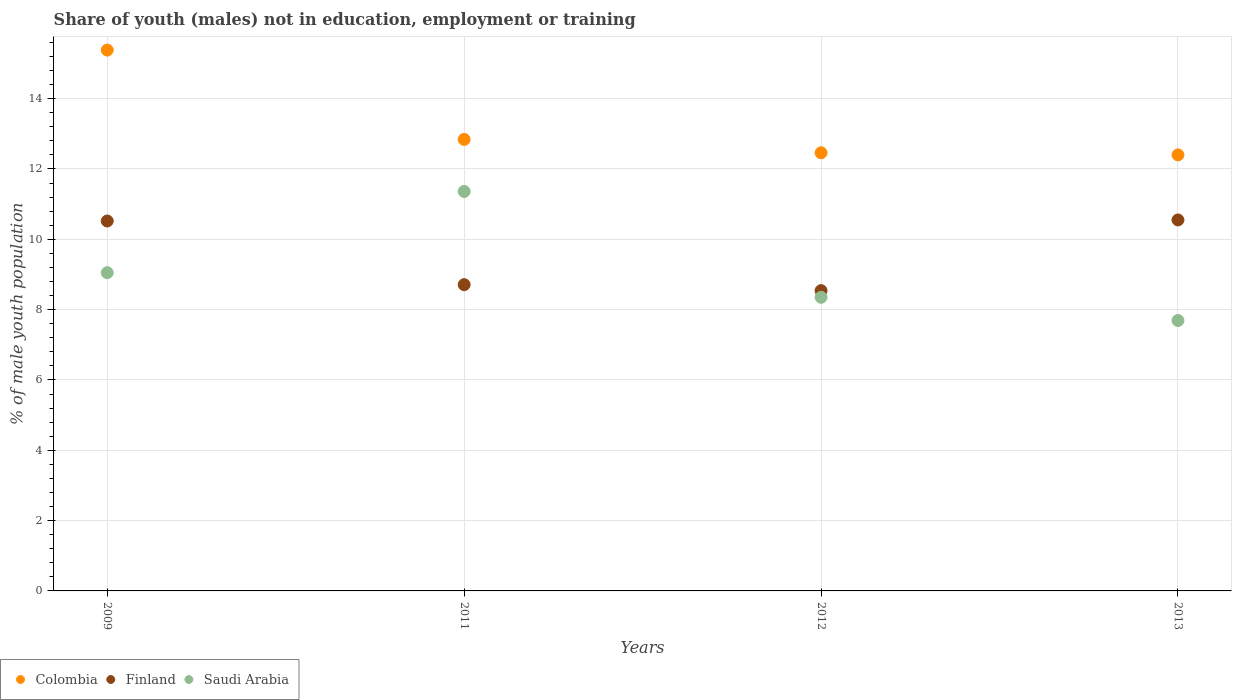What is the percentage of unemployed males population in in Finland in 2012?
Your answer should be very brief. 8.54. Across all years, what is the maximum percentage of unemployed males population in in Colombia?
Offer a very short reply. 15.38. Across all years, what is the minimum percentage of unemployed males population in in Finland?
Provide a short and direct response. 8.54. In which year was the percentage of unemployed males population in in Saudi Arabia minimum?
Offer a very short reply. 2013. What is the total percentage of unemployed males population in in Colombia in the graph?
Provide a succinct answer. 53.08. What is the difference between the percentage of unemployed males population in in Saudi Arabia in 2012 and that in 2013?
Provide a short and direct response. 0.66. What is the difference between the percentage of unemployed males population in in Finland in 2013 and the percentage of unemployed males population in in Colombia in 2009?
Your answer should be compact. -4.83. What is the average percentage of unemployed males population in in Colombia per year?
Your answer should be very brief. 13.27. In the year 2012, what is the difference between the percentage of unemployed males population in in Colombia and percentage of unemployed males population in in Saudi Arabia?
Keep it short and to the point. 4.11. What is the ratio of the percentage of unemployed males population in in Saudi Arabia in 2011 to that in 2013?
Provide a short and direct response. 1.48. Is the difference between the percentage of unemployed males population in in Colombia in 2011 and 2013 greater than the difference between the percentage of unemployed males population in in Saudi Arabia in 2011 and 2013?
Your response must be concise. No. What is the difference between the highest and the second highest percentage of unemployed males population in in Saudi Arabia?
Make the answer very short. 2.31. What is the difference between the highest and the lowest percentage of unemployed males population in in Colombia?
Give a very brief answer. 2.98. In how many years, is the percentage of unemployed males population in in Saudi Arabia greater than the average percentage of unemployed males population in in Saudi Arabia taken over all years?
Offer a very short reply. 1. Is the percentage of unemployed males population in in Colombia strictly less than the percentage of unemployed males population in in Finland over the years?
Ensure brevity in your answer.  No. How many years are there in the graph?
Offer a very short reply. 4. Are the values on the major ticks of Y-axis written in scientific E-notation?
Provide a short and direct response. No. Does the graph contain any zero values?
Offer a terse response. No. Does the graph contain grids?
Your answer should be compact. Yes. Where does the legend appear in the graph?
Ensure brevity in your answer.  Bottom left. How are the legend labels stacked?
Offer a terse response. Horizontal. What is the title of the graph?
Provide a succinct answer. Share of youth (males) not in education, employment or training. What is the label or title of the X-axis?
Keep it short and to the point. Years. What is the label or title of the Y-axis?
Your answer should be compact. % of male youth population. What is the % of male youth population in Colombia in 2009?
Offer a very short reply. 15.38. What is the % of male youth population in Finland in 2009?
Make the answer very short. 10.52. What is the % of male youth population of Saudi Arabia in 2009?
Offer a very short reply. 9.05. What is the % of male youth population in Colombia in 2011?
Keep it short and to the point. 12.84. What is the % of male youth population in Finland in 2011?
Your answer should be very brief. 8.71. What is the % of male youth population in Saudi Arabia in 2011?
Your response must be concise. 11.36. What is the % of male youth population of Colombia in 2012?
Keep it short and to the point. 12.46. What is the % of male youth population of Finland in 2012?
Ensure brevity in your answer.  8.54. What is the % of male youth population in Saudi Arabia in 2012?
Your answer should be compact. 8.35. What is the % of male youth population of Colombia in 2013?
Your response must be concise. 12.4. What is the % of male youth population of Finland in 2013?
Keep it short and to the point. 10.55. What is the % of male youth population in Saudi Arabia in 2013?
Your answer should be very brief. 7.69. Across all years, what is the maximum % of male youth population of Colombia?
Provide a succinct answer. 15.38. Across all years, what is the maximum % of male youth population in Finland?
Keep it short and to the point. 10.55. Across all years, what is the maximum % of male youth population of Saudi Arabia?
Keep it short and to the point. 11.36. Across all years, what is the minimum % of male youth population of Colombia?
Ensure brevity in your answer.  12.4. Across all years, what is the minimum % of male youth population of Finland?
Your answer should be very brief. 8.54. Across all years, what is the minimum % of male youth population in Saudi Arabia?
Provide a short and direct response. 7.69. What is the total % of male youth population of Colombia in the graph?
Ensure brevity in your answer.  53.08. What is the total % of male youth population in Finland in the graph?
Ensure brevity in your answer.  38.32. What is the total % of male youth population of Saudi Arabia in the graph?
Ensure brevity in your answer.  36.45. What is the difference between the % of male youth population in Colombia in 2009 and that in 2011?
Provide a succinct answer. 2.54. What is the difference between the % of male youth population of Finland in 2009 and that in 2011?
Your response must be concise. 1.81. What is the difference between the % of male youth population in Saudi Arabia in 2009 and that in 2011?
Your answer should be very brief. -2.31. What is the difference between the % of male youth population in Colombia in 2009 and that in 2012?
Keep it short and to the point. 2.92. What is the difference between the % of male youth population of Finland in 2009 and that in 2012?
Offer a very short reply. 1.98. What is the difference between the % of male youth population in Colombia in 2009 and that in 2013?
Your answer should be compact. 2.98. What is the difference between the % of male youth population in Finland in 2009 and that in 2013?
Keep it short and to the point. -0.03. What is the difference between the % of male youth population of Saudi Arabia in 2009 and that in 2013?
Ensure brevity in your answer.  1.36. What is the difference between the % of male youth population in Colombia in 2011 and that in 2012?
Offer a very short reply. 0.38. What is the difference between the % of male youth population in Finland in 2011 and that in 2012?
Your answer should be very brief. 0.17. What is the difference between the % of male youth population in Saudi Arabia in 2011 and that in 2012?
Ensure brevity in your answer.  3.01. What is the difference between the % of male youth population of Colombia in 2011 and that in 2013?
Offer a very short reply. 0.44. What is the difference between the % of male youth population in Finland in 2011 and that in 2013?
Your response must be concise. -1.84. What is the difference between the % of male youth population in Saudi Arabia in 2011 and that in 2013?
Offer a terse response. 3.67. What is the difference between the % of male youth population in Colombia in 2012 and that in 2013?
Provide a short and direct response. 0.06. What is the difference between the % of male youth population of Finland in 2012 and that in 2013?
Offer a terse response. -2.01. What is the difference between the % of male youth population of Saudi Arabia in 2012 and that in 2013?
Offer a terse response. 0.66. What is the difference between the % of male youth population of Colombia in 2009 and the % of male youth population of Finland in 2011?
Give a very brief answer. 6.67. What is the difference between the % of male youth population of Colombia in 2009 and the % of male youth population of Saudi Arabia in 2011?
Offer a terse response. 4.02. What is the difference between the % of male youth population in Finland in 2009 and the % of male youth population in Saudi Arabia in 2011?
Ensure brevity in your answer.  -0.84. What is the difference between the % of male youth population of Colombia in 2009 and the % of male youth population of Finland in 2012?
Your answer should be compact. 6.84. What is the difference between the % of male youth population in Colombia in 2009 and the % of male youth population in Saudi Arabia in 2012?
Your answer should be very brief. 7.03. What is the difference between the % of male youth population in Finland in 2009 and the % of male youth population in Saudi Arabia in 2012?
Your answer should be compact. 2.17. What is the difference between the % of male youth population of Colombia in 2009 and the % of male youth population of Finland in 2013?
Your response must be concise. 4.83. What is the difference between the % of male youth population of Colombia in 2009 and the % of male youth population of Saudi Arabia in 2013?
Provide a succinct answer. 7.69. What is the difference between the % of male youth population in Finland in 2009 and the % of male youth population in Saudi Arabia in 2013?
Offer a very short reply. 2.83. What is the difference between the % of male youth population of Colombia in 2011 and the % of male youth population of Finland in 2012?
Give a very brief answer. 4.3. What is the difference between the % of male youth population in Colombia in 2011 and the % of male youth population in Saudi Arabia in 2012?
Give a very brief answer. 4.49. What is the difference between the % of male youth population of Finland in 2011 and the % of male youth population of Saudi Arabia in 2012?
Your answer should be compact. 0.36. What is the difference between the % of male youth population in Colombia in 2011 and the % of male youth population in Finland in 2013?
Offer a very short reply. 2.29. What is the difference between the % of male youth population of Colombia in 2011 and the % of male youth population of Saudi Arabia in 2013?
Offer a very short reply. 5.15. What is the difference between the % of male youth population in Colombia in 2012 and the % of male youth population in Finland in 2013?
Offer a terse response. 1.91. What is the difference between the % of male youth population of Colombia in 2012 and the % of male youth population of Saudi Arabia in 2013?
Provide a succinct answer. 4.77. What is the average % of male youth population of Colombia per year?
Ensure brevity in your answer.  13.27. What is the average % of male youth population of Finland per year?
Offer a terse response. 9.58. What is the average % of male youth population of Saudi Arabia per year?
Offer a terse response. 9.11. In the year 2009, what is the difference between the % of male youth population of Colombia and % of male youth population of Finland?
Your answer should be very brief. 4.86. In the year 2009, what is the difference between the % of male youth population in Colombia and % of male youth population in Saudi Arabia?
Your response must be concise. 6.33. In the year 2009, what is the difference between the % of male youth population in Finland and % of male youth population in Saudi Arabia?
Provide a succinct answer. 1.47. In the year 2011, what is the difference between the % of male youth population of Colombia and % of male youth population of Finland?
Ensure brevity in your answer.  4.13. In the year 2011, what is the difference between the % of male youth population of Colombia and % of male youth population of Saudi Arabia?
Give a very brief answer. 1.48. In the year 2011, what is the difference between the % of male youth population of Finland and % of male youth population of Saudi Arabia?
Offer a terse response. -2.65. In the year 2012, what is the difference between the % of male youth population in Colombia and % of male youth population in Finland?
Keep it short and to the point. 3.92. In the year 2012, what is the difference between the % of male youth population in Colombia and % of male youth population in Saudi Arabia?
Offer a terse response. 4.11. In the year 2012, what is the difference between the % of male youth population of Finland and % of male youth population of Saudi Arabia?
Your response must be concise. 0.19. In the year 2013, what is the difference between the % of male youth population in Colombia and % of male youth population in Finland?
Provide a short and direct response. 1.85. In the year 2013, what is the difference between the % of male youth population in Colombia and % of male youth population in Saudi Arabia?
Provide a succinct answer. 4.71. In the year 2013, what is the difference between the % of male youth population in Finland and % of male youth population in Saudi Arabia?
Offer a very short reply. 2.86. What is the ratio of the % of male youth population of Colombia in 2009 to that in 2011?
Keep it short and to the point. 1.2. What is the ratio of the % of male youth population in Finland in 2009 to that in 2011?
Provide a short and direct response. 1.21. What is the ratio of the % of male youth population in Saudi Arabia in 2009 to that in 2011?
Your answer should be compact. 0.8. What is the ratio of the % of male youth population in Colombia in 2009 to that in 2012?
Your answer should be very brief. 1.23. What is the ratio of the % of male youth population of Finland in 2009 to that in 2012?
Provide a succinct answer. 1.23. What is the ratio of the % of male youth population in Saudi Arabia in 2009 to that in 2012?
Make the answer very short. 1.08. What is the ratio of the % of male youth population of Colombia in 2009 to that in 2013?
Keep it short and to the point. 1.24. What is the ratio of the % of male youth population in Saudi Arabia in 2009 to that in 2013?
Provide a succinct answer. 1.18. What is the ratio of the % of male youth population in Colombia in 2011 to that in 2012?
Your response must be concise. 1.03. What is the ratio of the % of male youth population in Finland in 2011 to that in 2012?
Your answer should be very brief. 1.02. What is the ratio of the % of male youth population in Saudi Arabia in 2011 to that in 2012?
Keep it short and to the point. 1.36. What is the ratio of the % of male youth population in Colombia in 2011 to that in 2013?
Offer a terse response. 1.04. What is the ratio of the % of male youth population of Finland in 2011 to that in 2013?
Provide a short and direct response. 0.83. What is the ratio of the % of male youth population of Saudi Arabia in 2011 to that in 2013?
Your answer should be very brief. 1.48. What is the ratio of the % of male youth population of Colombia in 2012 to that in 2013?
Provide a succinct answer. 1. What is the ratio of the % of male youth population of Finland in 2012 to that in 2013?
Make the answer very short. 0.81. What is the ratio of the % of male youth population in Saudi Arabia in 2012 to that in 2013?
Your answer should be compact. 1.09. What is the difference between the highest and the second highest % of male youth population of Colombia?
Offer a terse response. 2.54. What is the difference between the highest and the second highest % of male youth population in Finland?
Provide a short and direct response. 0.03. What is the difference between the highest and the second highest % of male youth population in Saudi Arabia?
Ensure brevity in your answer.  2.31. What is the difference between the highest and the lowest % of male youth population in Colombia?
Provide a succinct answer. 2.98. What is the difference between the highest and the lowest % of male youth population of Finland?
Offer a very short reply. 2.01. What is the difference between the highest and the lowest % of male youth population of Saudi Arabia?
Keep it short and to the point. 3.67. 